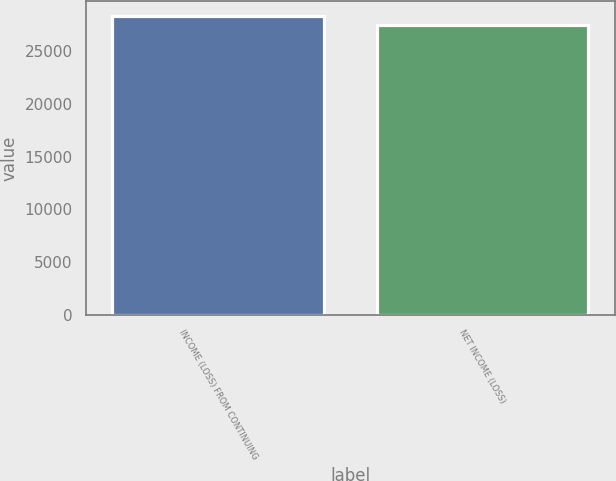Convert chart to OTSL. <chart><loc_0><loc_0><loc_500><loc_500><bar_chart><fcel>INCOME (LOSS) FROM CONTINUING<fcel>NET INCOME (LOSS)<nl><fcel>28338<fcel>27484<nl></chart> 